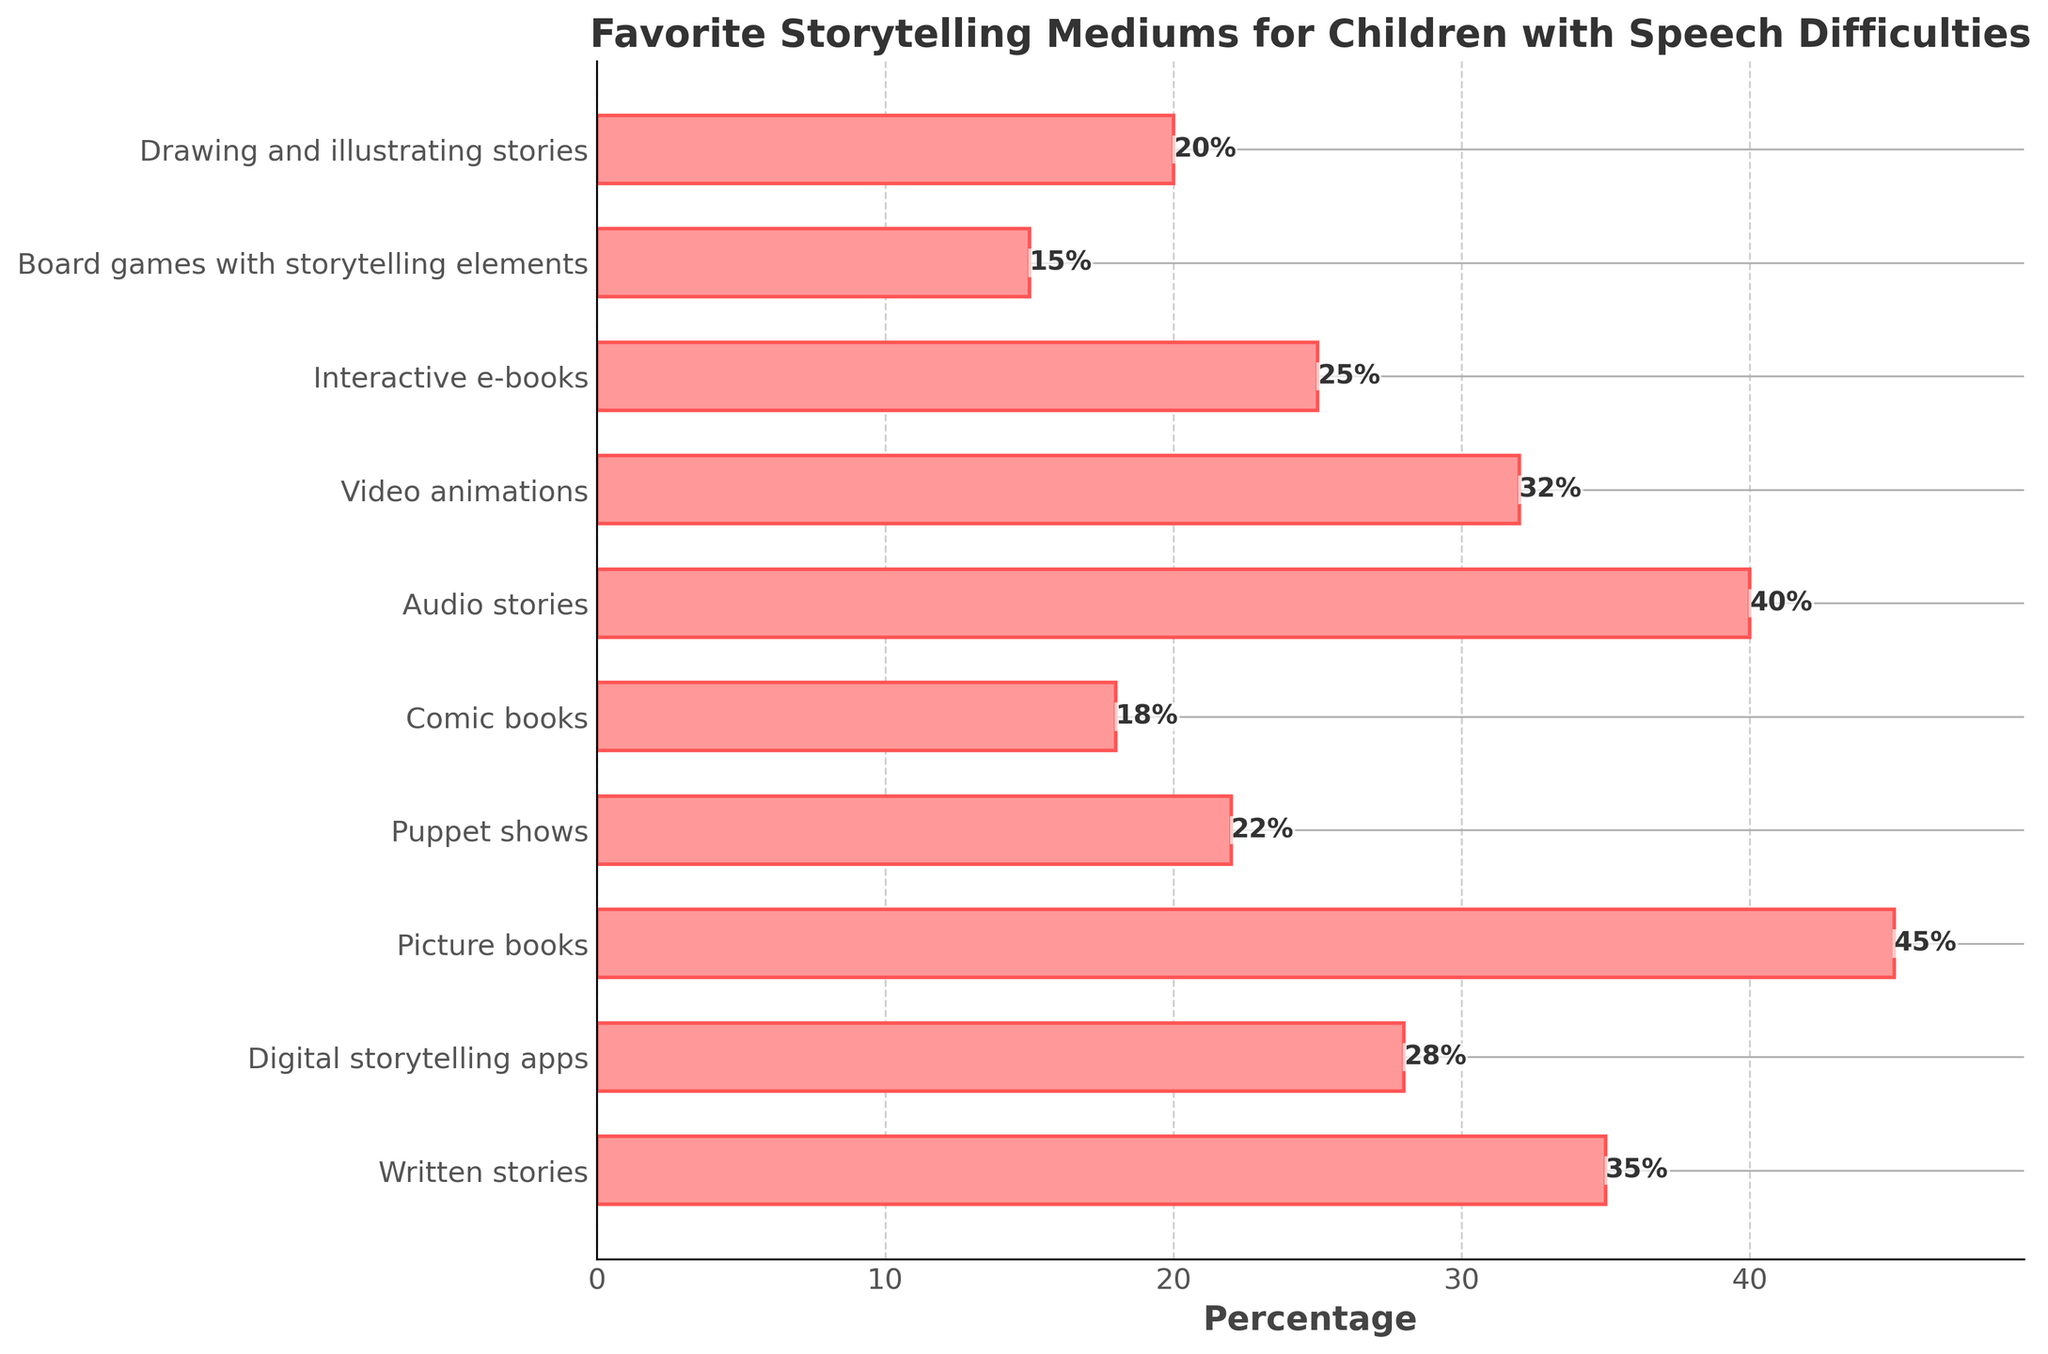What are the top three favorite storytelling mediums for children with speech difficulties based on their percentages? The top three are Picture books (45%), Audio stories (40%), and Written stories (35%).
Answer: Picture books, Audio stories, Written stories Which storytelling medium has a higher percentage: Digital storytelling apps or Video animations? Compare the percentages: Digital storytelling apps (28%) and Video animations (32%). Video animations have a higher percentage.
Answer: Video animations By how much does the percentage of Picture books exceed that of Written stories? Subtract the percentage of Written stories (35%) from the percentage of Picture books (45%). 45 - 35 = 10. So, Picture books exceed Written stories by 10%.
Answer: 10% What is the total percentage of children preferring Oral stories (Puppet shows + Audio stories)? Add the percentages of Puppet shows (22%) and Audio stories (40%). 22 + 40 = 62. So, the total is 62%.
Answer: 62% Which storytelling medium is the least favored among children with speech difficulties? Look for the medium with the lowest percentage. Board games with storytelling elements have the lowest percentage at 15%.
Answer: Board games with storytelling elements Is Drawing and illustrating stories more or less popular than Interactive e-books? Compare their percentages: Drawing and illustrating stories (20%) and Interactive e-books (25%). Drawing and illustrating stories is less popular.
Answer: Less popular Calculate the average percentage of preference for Comic books, Puppet shows, and Board games with storytelling elements. Add the percentages and divide by 3: (18 + 22 + 15) / 3 = 55 / 3 ≈ 18.33%. The average is approximately 18.33%.
Answer: 18.33% How much greater is the percentage for Audio stories compared to Puppet shows? Subtract the percentage of Puppet shows (22%) from the percentage of Audio stories (40%). 40 - 22 = 18. So, Audio stories are greater by 18%.
Answer: 18% Which storytelling mediums have a percentage greater than 25% but less than 35%? Look for mediums within the specified range. Digital storytelling apps (28%), Video animations (32%), and Written stories (35%) fall into this range.
Answer: Digital storytelling apps, Video animations, Written stories What is the combined percentage preference for mediums that primarily use visual elements (Picture books, Comic books, Drawing and illustrating stories)? Add the percentages of Picture books (45%), Comic books (18%), and Drawing and illustrating stories (20%). 45 + 18 + 20 = 83. The combined percentage is 83%.
Answer: 83% 